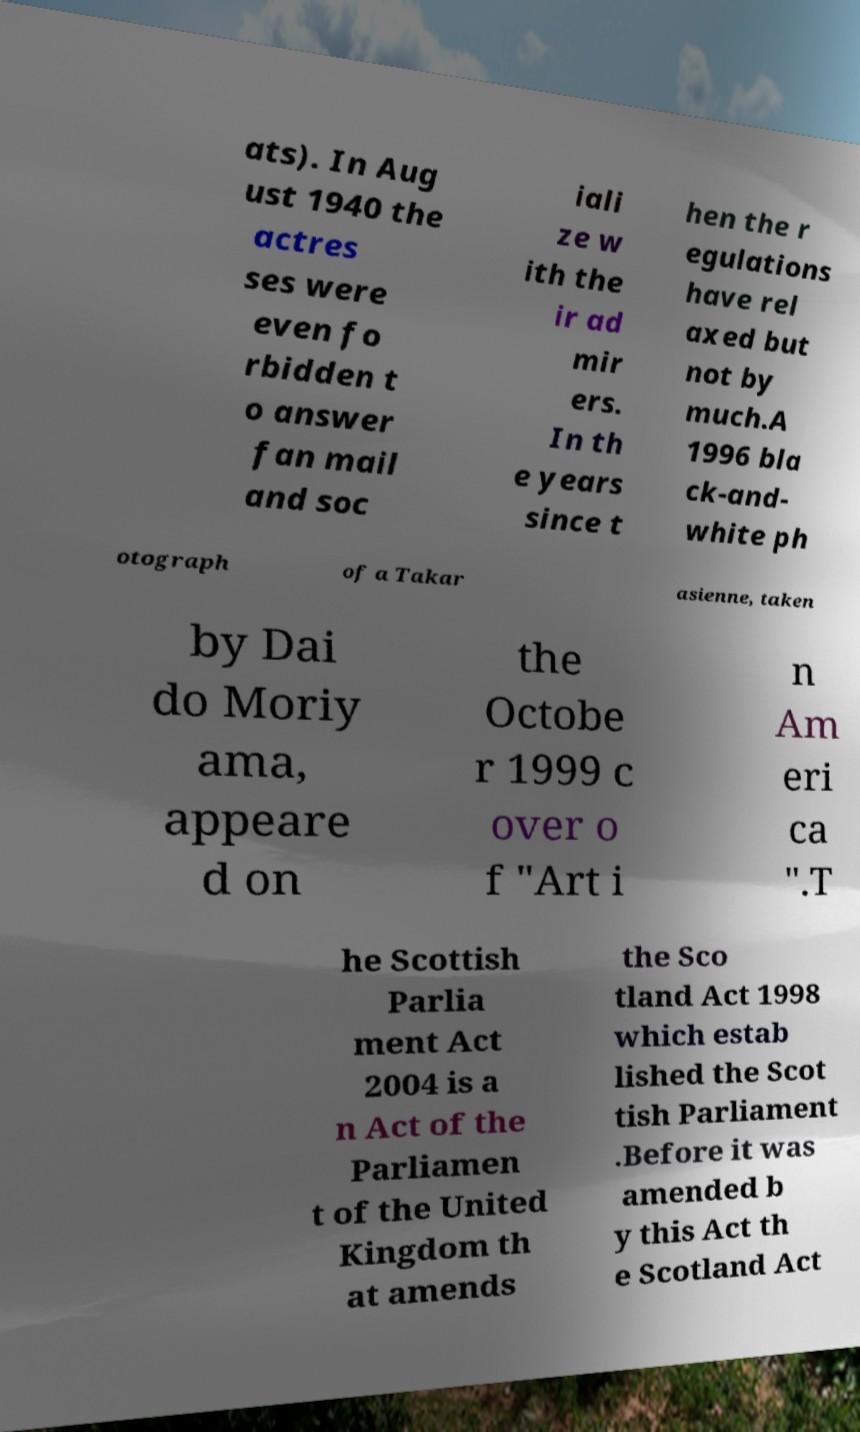Can you accurately transcribe the text from the provided image for me? ats). In Aug ust 1940 the actres ses were even fo rbidden t o answer fan mail and soc iali ze w ith the ir ad mir ers. In th e years since t hen the r egulations have rel axed but not by much.A 1996 bla ck-and- white ph otograph of a Takar asienne, taken by Dai do Moriy ama, appeare d on the Octobe r 1999 c over o f "Art i n Am eri ca ".T he Scottish Parlia ment Act 2004 is a n Act of the Parliamen t of the United Kingdom th at amends the Sco tland Act 1998 which estab lished the Scot tish Parliament .Before it was amended b y this Act th e Scotland Act 